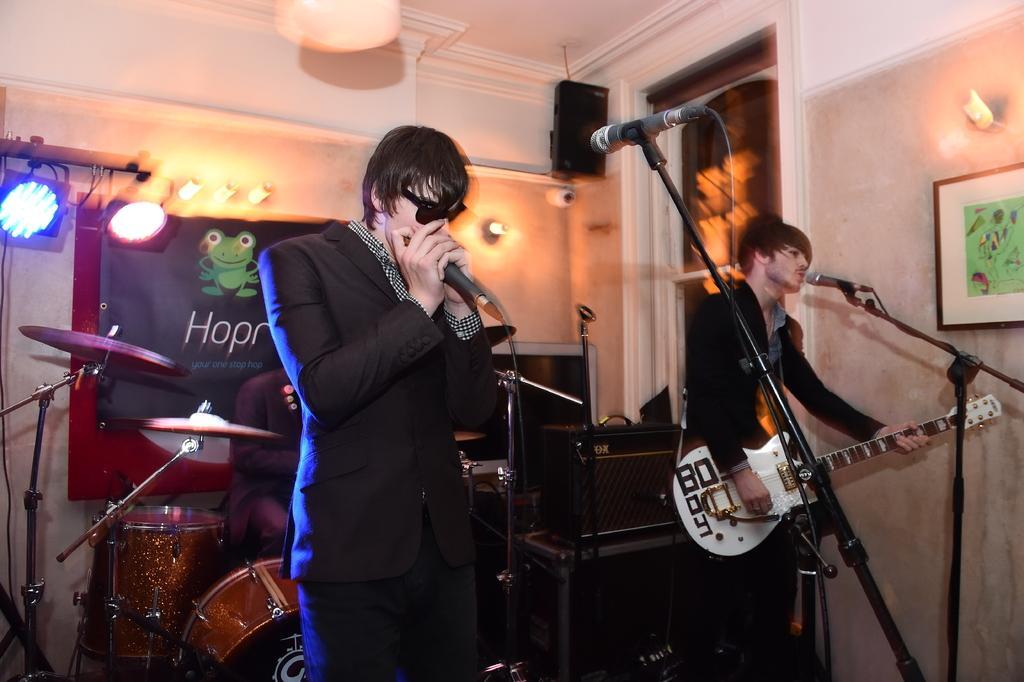Please provide a concise description of this image. In this picture we can see three people two people are standing in front of a microphone one is seated on the chair, one man is holding a microphone while another man playing a guitar in the background we can see some musical instruments and lights. 